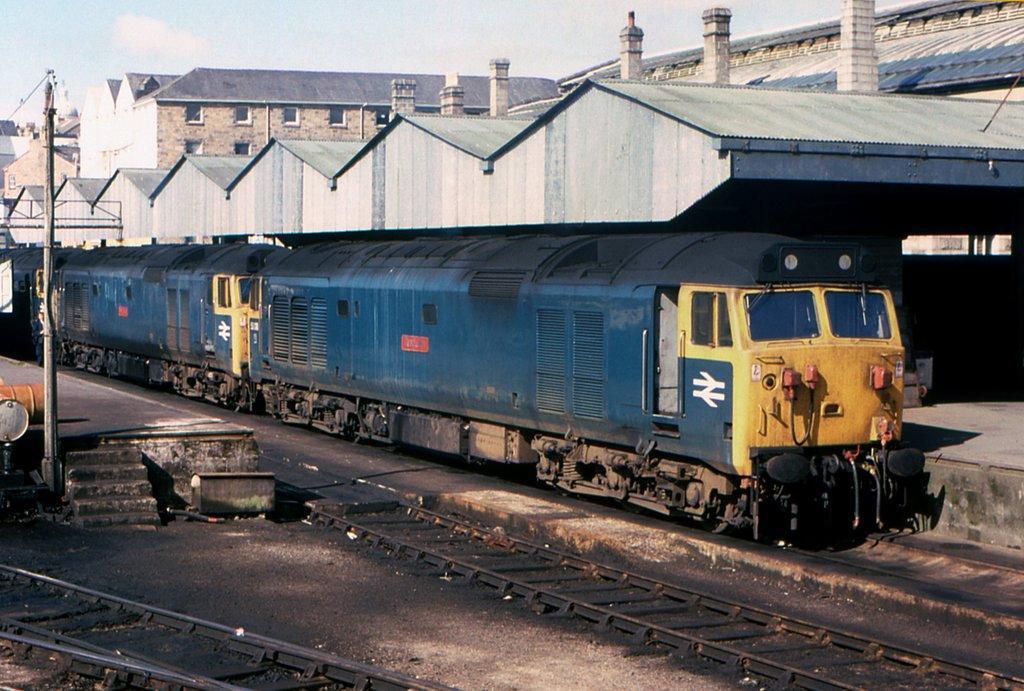In one or two sentences, can you explain what this image depicts? In this picture I can see trains on the track, side there are some buildings. 